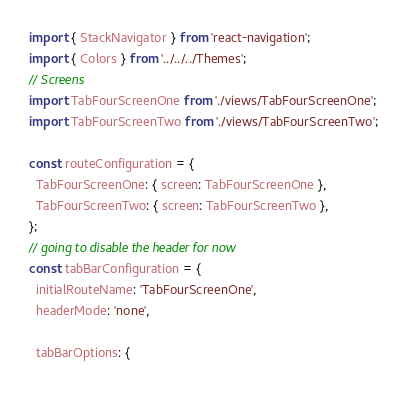<code> <loc_0><loc_0><loc_500><loc_500><_JavaScript_>import { StackNavigator } from 'react-navigation';
import { Colors } from '../../../Themes';
// Screens
import TabFourScreenOne from './views/TabFourScreenOne';
import TabFourScreenTwo from './views/TabFourScreenTwo';

const routeConfiguration = {
  TabFourScreenOne: { screen: TabFourScreenOne },
  TabFourScreenTwo: { screen: TabFourScreenTwo },
};
// going to disable the header for now
const tabBarConfiguration = {
  initialRouteName: 'TabFourScreenOne',
  headerMode: 'none',

  tabBarOptions: {</code> 